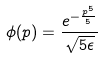Convert formula to latex. <formula><loc_0><loc_0><loc_500><loc_500>\phi ( p ) = \frac { e ^ { - \frac { p ^ { 5 } } { 5 } } } { \sqrt { 5 \epsilon } }</formula> 